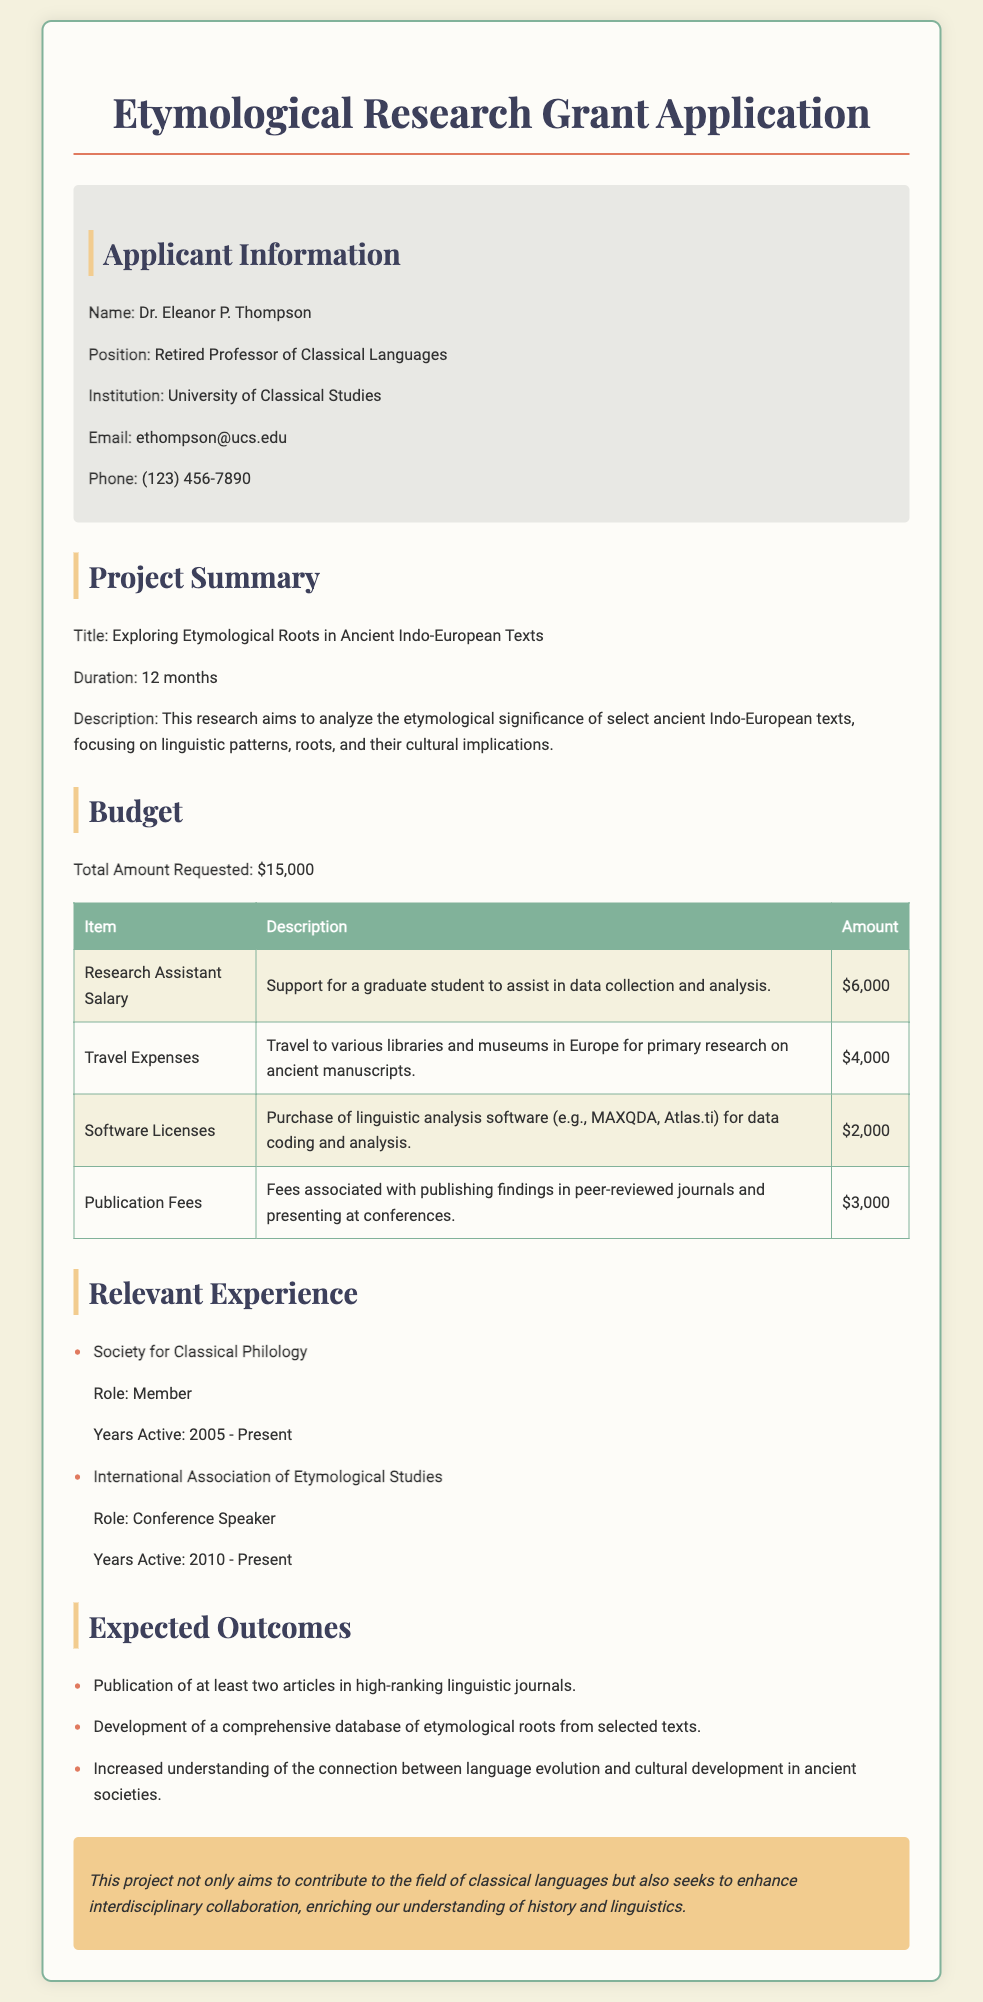What is the name of the applicant? The applicant's name is provided in the document under the applicant information section.
Answer: Dr. Eleanor P. Thompson What is the total amount requested for the grant? The total amount requested for the grant is stated in the budget section of the document.
Answer: $15,000 What are the years of active membership in the Society for Classical Philology? The years of active membership indicate the time span as mentioned in the experience section.
Answer: 2005 - Present How much is allocated for publication fees? The budget table specifies the amount allocated for publication fees.
Answer: $3,000 What is the title of the research project? The title of the research project is mentioned in the project summary section.
Answer: Exploring Etymological Roots in Ancient Indo-European Texts What kind of support is the research assistant salary intended for? The description for the research assistant salary in the budget table provides details on its purpose.
Answer: Assistance in data collection and analysis What is one of the expected outcomes of the research? The expected outcomes section lists several anticipated results from the research project.
Answer: Publication of at least two articles in high-ranking linguistic journals How much is allocated for travel expenses? The specific amount set aside for travel expenses is listed in the budget table.
Answer: $4,000 What role does Dr. Eleanor P. Thompson hold in the International Association of Etymological Studies? The document mentions her role in that association under relevant experience.
Answer: Conference Speaker 